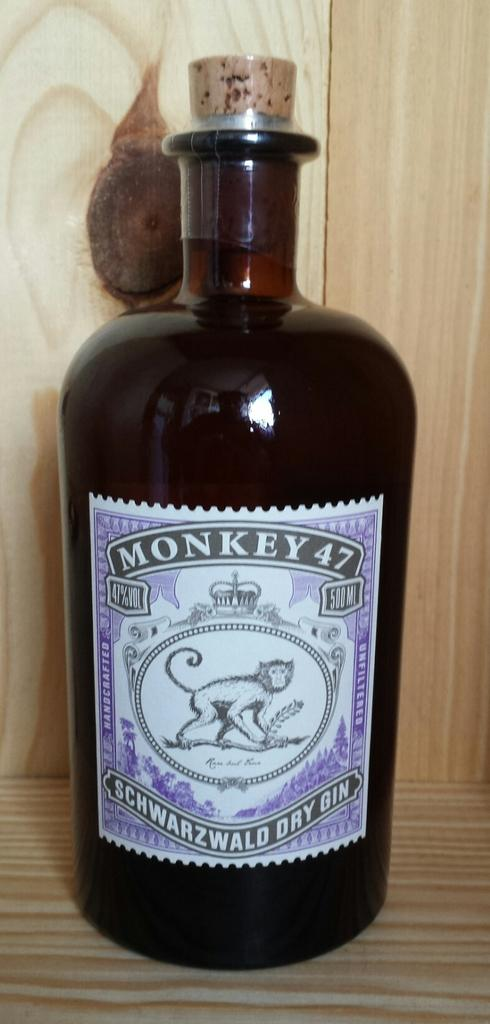<image>
Summarize the visual content of the image. A corked bottle of Monkey 47 is surrounded by wood. 